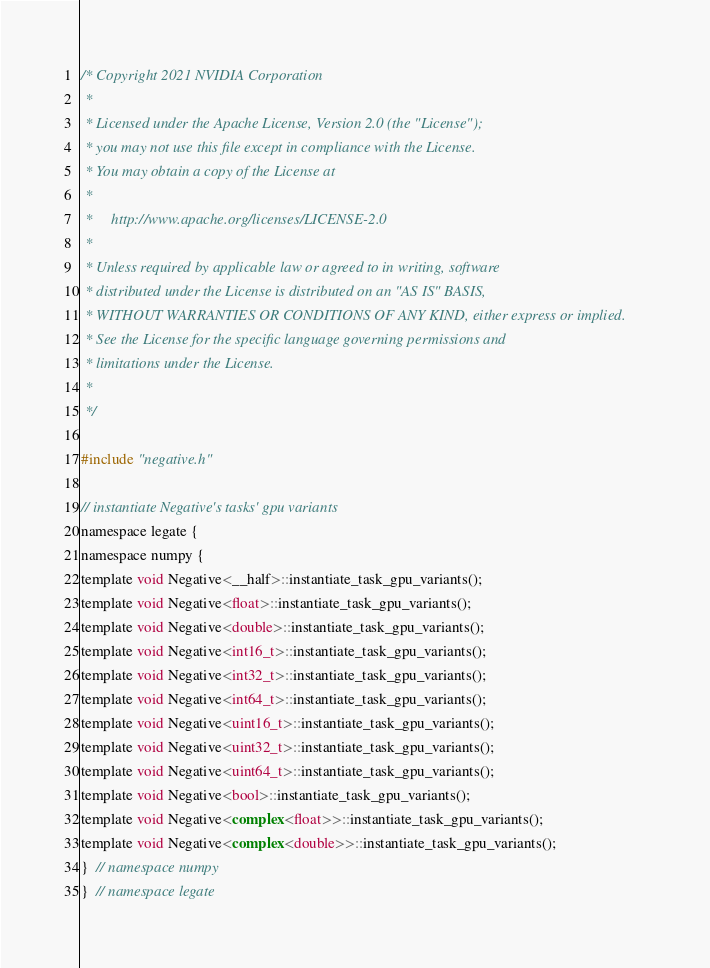<code> <loc_0><loc_0><loc_500><loc_500><_Cuda_>/* Copyright 2021 NVIDIA Corporation
 *
 * Licensed under the Apache License, Version 2.0 (the "License");
 * you may not use this file except in compliance with the License.
 * You may obtain a copy of the License at
 *
 *     http://www.apache.org/licenses/LICENSE-2.0
 *
 * Unless required by applicable law or agreed to in writing, software
 * distributed under the License is distributed on an "AS IS" BASIS,
 * WITHOUT WARRANTIES OR CONDITIONS OF ANY KIND, either express or implied.
 * See the License for the specific language governing permissions and
 * limitations under the License.
 *
 */

#include "negative.h"

// instantiate Negative's tasks' gpu variants
namespace legate {
namespace numpy {
template void Negative<__half>::instantiate_task_gpu_variants();
template void Negative<float>::instantiate_task_gpu_variants();
template void Negative<double>::instantiate_task_gpu_variants();
template void Negative<int16_t>::instantiate_task_gpu_variants();
template void Negative<int32_t>::instantiate_task_gpu_variants();
template void Negative<int64_t>::instantiate_task_gpu_variants();
template void Negative<uint16_t>::instantiate_task_gpu_variants();
template void Negative<uint32_t>::instantiate_task_gpu_variants();
template void Negative<uint64_t>::instantiate_task_gpu_variants();
template void Negative<bool>::instantiate_task_gpu_variants();
template void Negative<complex<float>>::instantiate_task_gpu_variants();
template void Negative<complex<double>>::instantiate_task_gpu_variants();
}  // namespace numpy
}  // namespace legate
</code> 